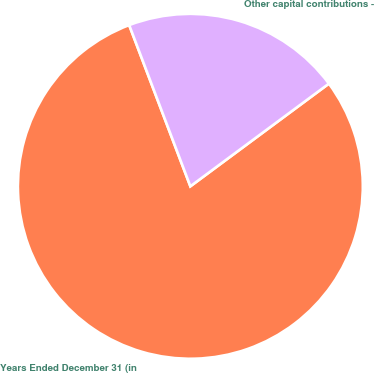<chart> <loc_0><loc_0><loc_500><loc_500><pie_chart><fcel>Years Ended December 31 (in<fcel>Other capital contributions -<nl><fcel>79.38%<fcel>20.62%<nl></chart> 